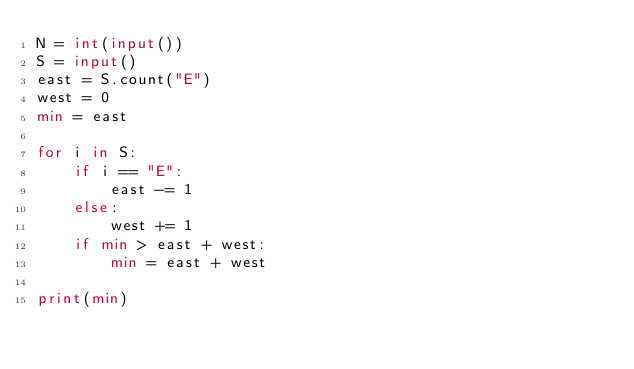Convert code to text. <code><loc_0><loc_0><loc_500><loc_500><_Python_>N = int(input())
S = input()
east = S.count("E")
west = 0
min = east

for i in S:
    if i == "E":
        east -= 1
    else:
        west += 1
    if min > east + west:
        min = east + west

print(min)
</code> 